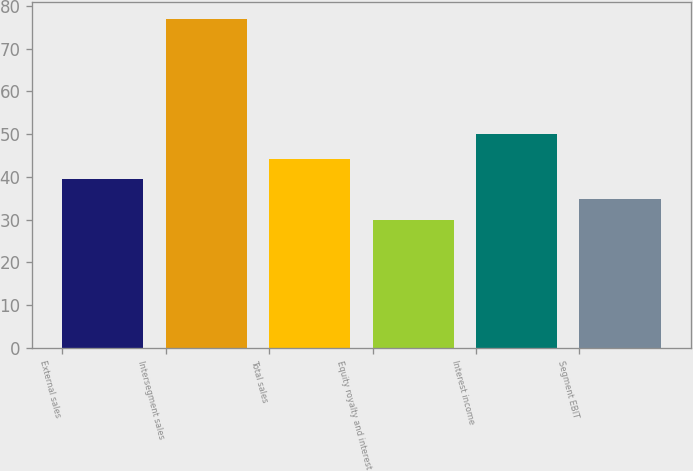<chart> <loc_0><loc_0><loc_500><loc_500><bar_chart><fcel>External sales<fcel>Intersegment sales<fcel>Total sales<fcel>Equity royalty and interest<fcel>Interest income<fcel>Segment EBIT<nl><fcel>39.4<fcel>77<fcel>44.1<fcel>30<fcel>50<fcel>34.7<nl></chart> 